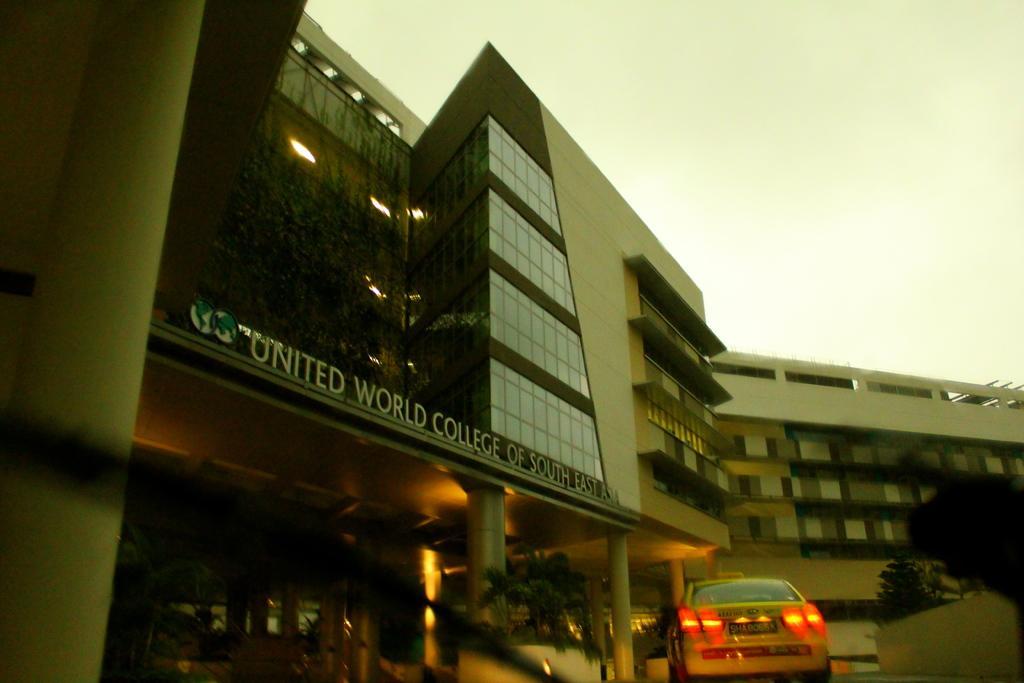Describe this image in one or two sentences. Here in this picture we can see buildings present all over there and in the front we can see plants and trees present here and there and on the road we can see a taxi present and we can see windows on the buildings here and there. 